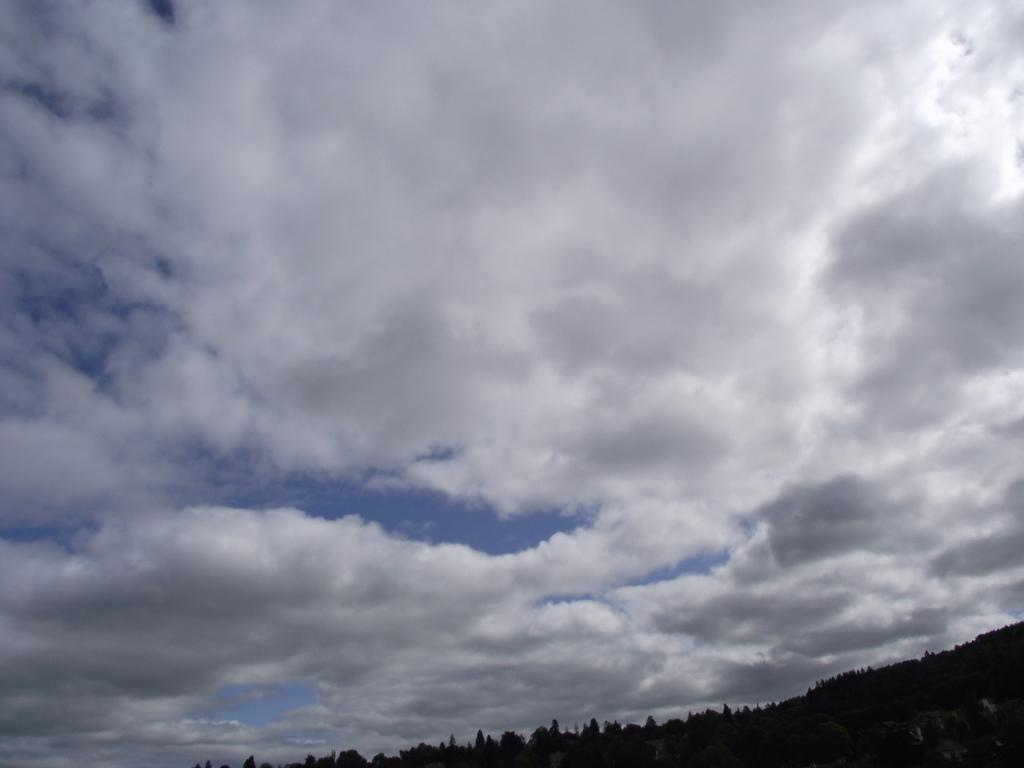Where was the image taken? The image was clicked outside the city. What can be seen in the foreground of the image? There are trees and other objects in the foreground of the image. What is visible in the background of the image? The sky is visible in the background of the image. What is the condition of the sky in the image? The sky is full of clouds. What type of observation can be made about the kitty in the image? There is no kitty present in the image, so no observation can be made about it. 